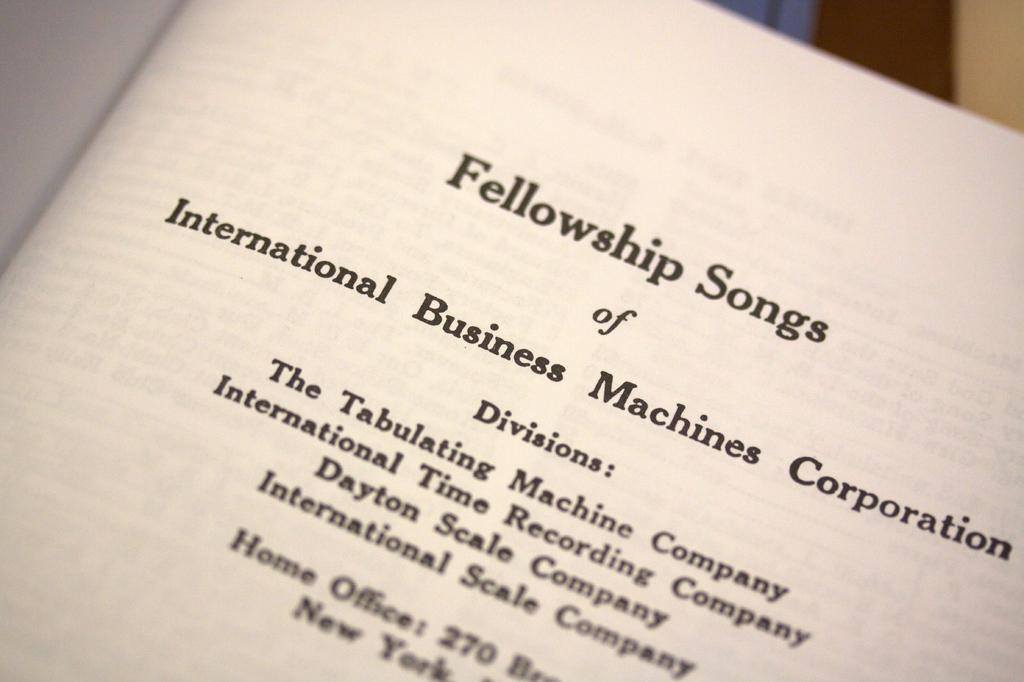What is the title at the top of the page?
Your response must be concise. Fellowship songs. 